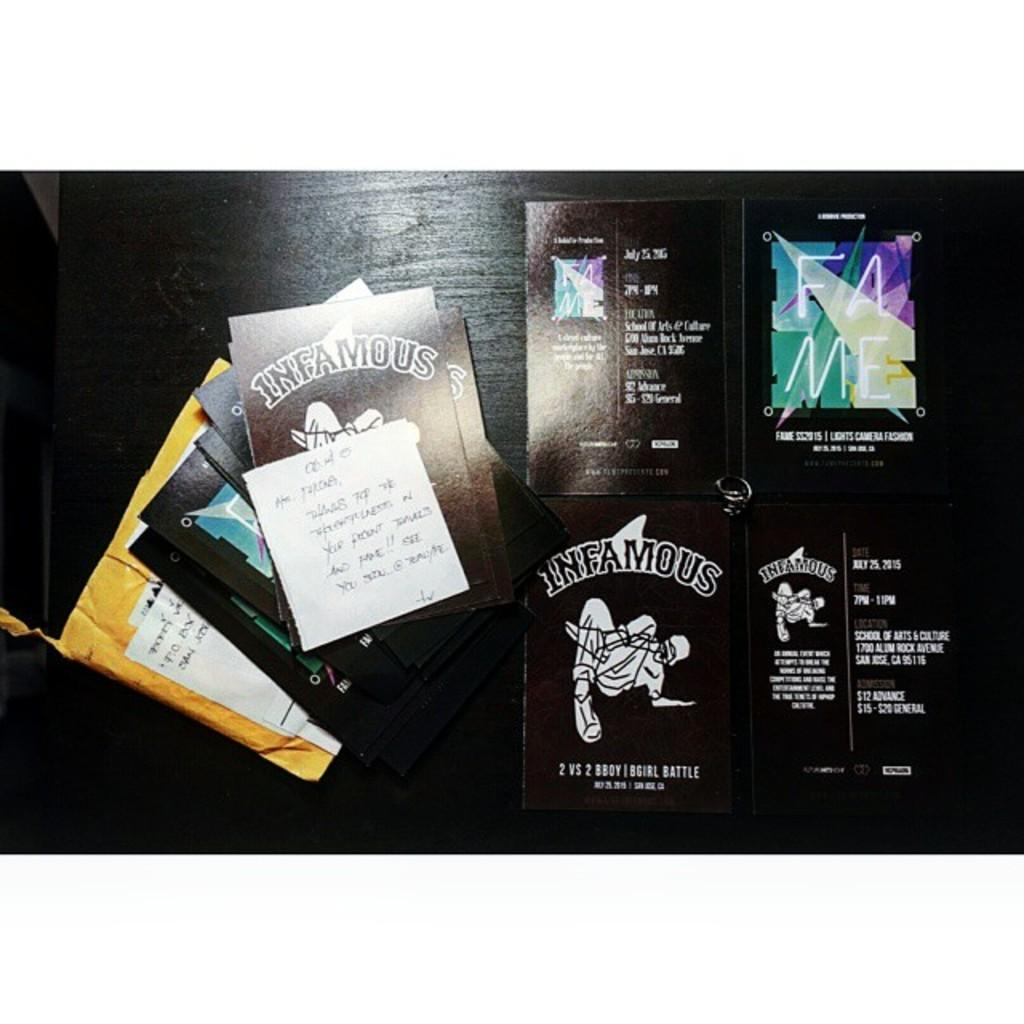<image>
Write a terse but informative summary of the picture. Brown colored cards by Infamous sit in piles on a surface. 